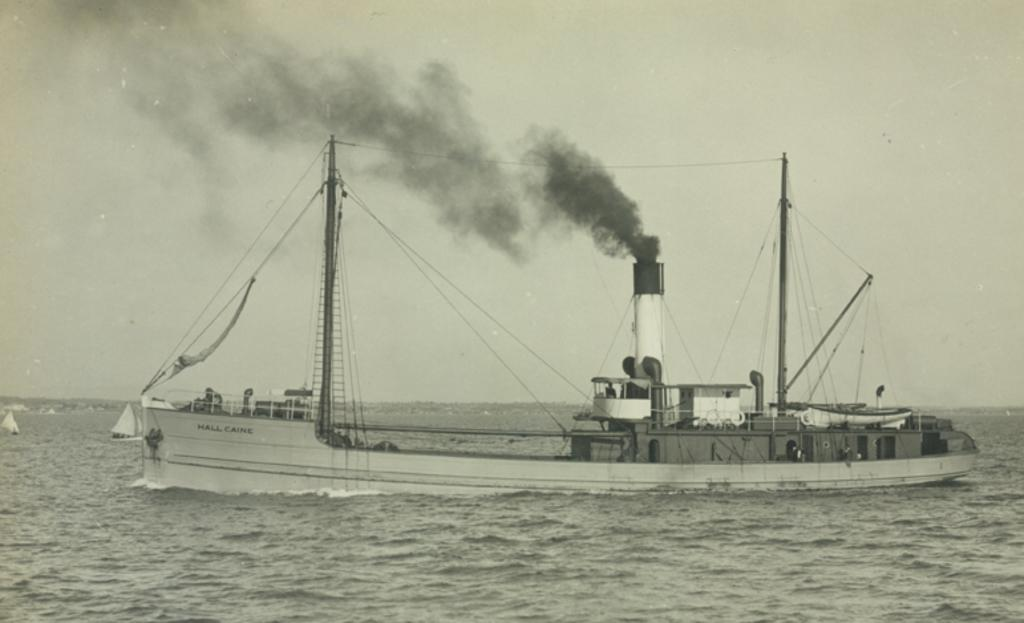What is the color scheme of the image? The image is black and white. What is the main subject of the image? There is a ship in the image. Where is the ship located? The ship is on the water. What can be seen in the background of the image? There is sky and smoke visible in the background of the image. What type of toy can be seen floating in the water next to the ship? There is no toy present in the image; it only features a ship on the water. Can you describe the worm that is crawling on the ship's deck? There is no worm present on the ship's deck in the image. 